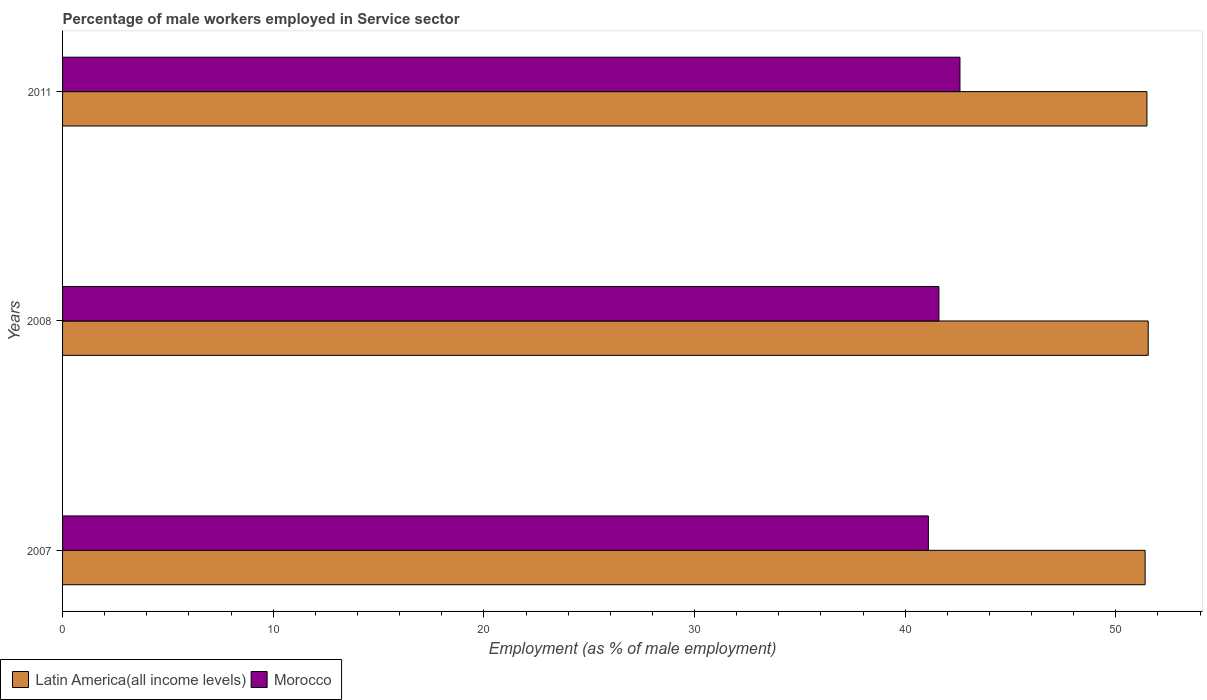How many different coloured bars are there?
Keep it short and to the point. 2. How many groups of bars are there?
Your answer should be very brief. 3. Are the number of bars on each tick of the Y-axis equal?
Keep it short and to the point. Yes. How many bars are there on the 2nd tick from the bottom?
Offer a terse response. 2. In how many cases, is the number of bars for a given year not equal to the number of legend labels?
Give a very brief answer. 0. What is the percentage of male workers employed in Service sector in Latin America(all income levels) in 2011?
Keep it short and to the point. 51.47. Across all years, what is the maximum percentage of male workers employed in Service sector in Latin America(all income levels)?
Offer a very short reply. 51.54. Across all years, what is the minimum percentage of male workers employed in Service sector in Latin America(all income levels)?
Your answer should be compact. 51.39. In which year was the percentage of male workers employed in Service sector in Latin America(all income levels) maximum?
Your answer should be very brief. 2008. In which year was the percentage of male workers employed in Service sector in Latin America(all income levels) minimum?
Keep it short and to the point. 2007. What is the total percentage of male workers employed in Service sector in Latin America(all income levels) in the graph?
Offer a very short reply. 154.4. What is the difference between the percentage of male workers employed in Service sector in Latin America(all income levels) in 2008 and that in 2011?
Make the answer very short. 0.06. What is the difference between the percentage of male workers employed in Service sector in Latin America(all income levels) in 2011 and the percentage of male workers employed in Service sector in Morocco in 2007?
Your answer should be very brief. 10.37. What is the average percentage of male workers employed in Service sector in Morocco per year?
Keep it short and to the point. 41.77. In the year 2008, what is the difference between the percentage of male workers employed in Service sector in Latin America(all income levels) and percentage of male workers employed in Service sector in Morocco?
Keep it short and to the point. 9.94. What is the ratio of the percentage of male workers employed in Service sector in Latin America(all income levels) in 2007 to that in 2011?
Offer a very short reply. 1. Is the percentage of male workers employed in Service sector in Latin America(all income levels) in 2007 less than that in 2008?
Offer a very short reply. Yes. What is the difference between the highest and the second highest percentage of male workers employed in Service sector in Latin America(all income levels)?
Your response must be concise. 0.06. What is the difference between the highest and the lowest percentage of male workers employed in Service sector in Latin America(all income levels)?
Keep it short and to the point. 0.15. In how many years, is the percentage of male workers employed in Service sector in Morocco greater than the average percentage of male workers employed in Service sector in Morocco taken over all years?
Your answer should be compact. 1. Is the sum of the percentage of male workers employed in Service sector in Morocco in 2007 and 2011 greater than the maximum percentage of male workers employed in Service sector in Latin America(all income levels) across all years?
Provide a short and direct response. Yes. What does the 2nd bar from the top in 2011 represents?
Offer a very short reply. Latin America(all income levels). What does the 2nd bar from the bottom in 2008 represents?
Give a very brief answer. Morocco. How many bars are there?
Give a very brief answer. 6. Are all the bars in the graph horizontal?
Offer a terse response. Yes. How many years are there in the graph?
Provide a short and direct response. 3. What is the difference between two consecutive major ticks on the X-axis?
Offer a very short reply. 10. Are the values on the major ticks of X-axis written in scientific E-notation?
Offer a very short reply. No. How are the legend labels stacked?
Keep it short and to the point. Horizontal. What is the title of the graph?
Ensure brevity in your answer.  Percentage of male workers employed in Service sector. What is the label or title of the X-axis?
Your answer should be compact. Employment (as % of male employment). What is the Employment (as % of male employment) of Latin America(all income levels) in 2007?
Provide a short and direct response. 51.39. What is the Employment (as % of male employment) of Morocco in 2007?
Keep it short and to the point. 41.1. What is the Employment (as % of male employment) of Latin America(all income levels) in 2008?
Your answer should be very brief. 51.54. What is the Employment (as % of male employment) in Morocco in 2008?
Provide a succinct answer. 41.6. What is the Employment (as % of male employment) of Latin America(all income levels) in 2011?
Provide a short and direct response. 51.47. What is the Employment (as % of male employment) in Morocco in 2011?
Your answer should be very brief. 42.6. Across all years, what is the maximum Employment (as % of male employment) of Latin America(all income levels)?
Ensure brevity in your answer.  51.54. Across all years, what is the maximum Employment (as % of male employment) of Morocco?
Give a very brief answer. 42.6. Across all years, what is the minimum Employment (as % of male employment) of Latin America(all income levels)?
Keep it short and to the point. 51.39. Across all years, what is the minimum Employment (as % of male employment) in Morocco?
Provide a short and direct response. 41.1. What is the total Employment (as % of male employment) of Latin America(all income levels) in the graph?
Keep it short and to the point. 154.4. What is the total Employment (as % of male employment) of Morocco in the graph?
Provide a succinct answer. 125.3. What is the difference between the Employment (as % of male employment) in Latin America(all income levels) in 2007 and that in 2008?
Make the answer very short. -0.15. What is the difference between the Employment (as % of male employment) in Latin America(all income levels) in 2007 and that in 2011?
Provide a short and direct response. -0.08. What is the difference between the Employment (as % of male employment) in Latin America(all income levels) in 2008 and that in 2011?
Offer a very short reply. 0.06. What is the difference between the Employment (as % of male employment) in Morocco in 2008 and that in 2011?
Make the answer very short. -1. What is the difference between the Employment (as % of male employment) in Latin America(all income levels) in 2007 and the Employment (as % of male employment) in Morocco in 2008?
Provide a short and direct response. 9.79. What is the difference between the Employment (as % of male employment) of Latin America(all income levels) in 2007 and the Employment (as % of male employment) of Morocco in 2011?
Your response must be concise. 8.79. What is the difference between the Employment (as % of male employment) of Latin America(all income levels) in 2008 and the Employment (as % of male employment) of Morocco in 2011?
Offer a very short reply. 8.94. What is the average Employment (as % of male employment) in Latin America(all income levels) per year?
Provide a succinct answer. 51.47. What is the average Employment (as % of male employment) of Morocco per year?
Your answer should be compact. 41.77. In the year 2007, what is the difference between the Employment (as % of male employment) in Latin America(all income levels) and Employment (as % of male employment) in Morocco?
Ensure brevity in your answer.  10.29. In the year 2008, what is the difference between the Employment (as % of male employment) in Latin America(all income levels) and Employment (as % of male employment) in Morocco?
Provide a short and direct response. 9.94. In the year 2011, what is the difference between the Employment (as % of male employment) of Latin America(all income levels) and Employment (as % of male employment) of Morocco?
Keep it short and to the point. 8.87. What is the ratio of the Employment (as % of male employment) in Latin America(all income levels) in 2007 to that in 2011?
Your response must be concise. 1. What is the ratio of the Employment (as % of male employment) in Morocco in 2007 to that in 2011?
Your answer should be very brief. 0.96. What is the ratio of the Employment (as % of male employment) of Morocco in 2008 to that in 2011?
Your answer should be very brief. 0.98. What is the difference between the highest and the second highest Employment (as % of male employment) in Latin America(all income levels)?
Provide a succinct answer. 0.06. What is the difference between the highest and the lowest Employment (as % of male employment) of Latin America(all income levels)?
Offer a terse response. 0.15. What is the difference between the highest and the lowest Employment (as % of male employment) in Morocco?
Your answer should be very brief. 1.5. 